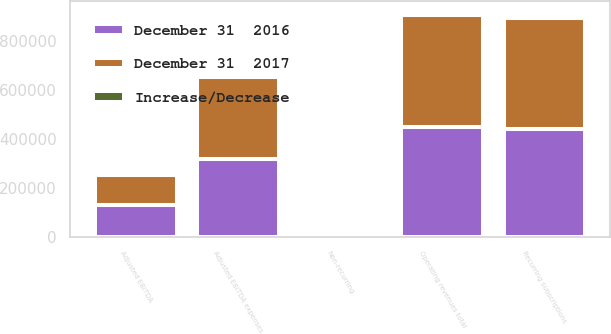Convert chart to OTSL. <chart><loc_0><loc_0><loc_500><loc_500><stacked_bar_chart><ecel><fcel>Recurring subscriptions<fcel>Non-recurring<fcel>Operating revenues total<fcel>Adjusted EBITDA expenses<fcel>Adjusted EBITDA<nl><fcel>December 31  2017<fcel>452253<fcel>6016<fcel>458269<fcel>332645<fcel>125624<nl><fcel>December 31  2016<fcel>439864<fcel>8489<fcel>448353<fcel>319846<fcel>128507<nl><fcel>Increase/Decrease<fcel>12389<fcel>2473<fcel>9916<fcel>12799<fcel>2883<nl></chart> 